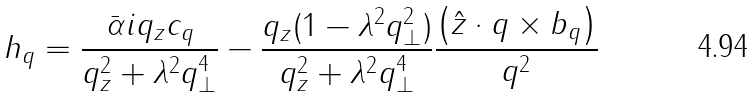<formula> <loc_0><loc_0><loc_500><loc_500>h _ { q } = \frac { \bar { \alpha } i q _ { z } c _ { q } } { q _ { z } ^ { 2 } + \lambda ^ { 2 } q _ { \perp } ^ { 4 } } - \frac { q _ { z } ( 1 - \lambda ^ { 2 } q _ { \perp } ^ { 2 } ) } { q _ { z } ^ { 2 } + \lambda ^ { 2 } q _ { \perp } ^ { 4 } } \frac { \left ( { \hat { z } \cdot q \times b _ { q } } \right ) } { q ^ { 2 } }</formula> 